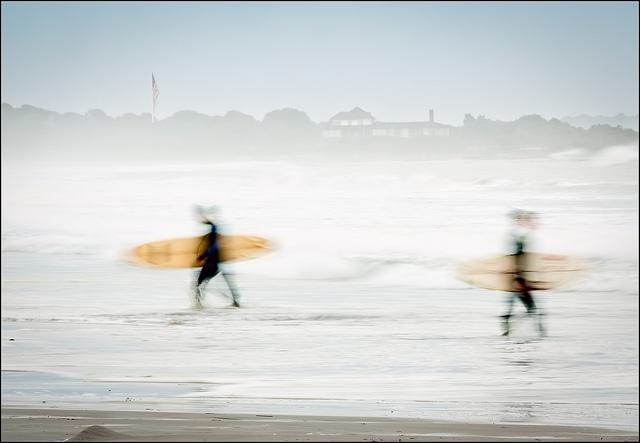How many blurry figures are passing the ocean with a surfboard in their hands? two 